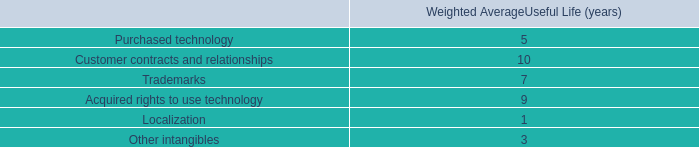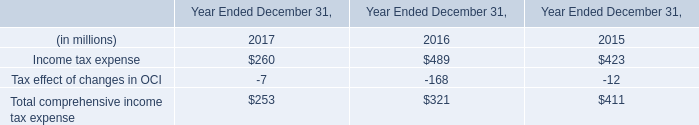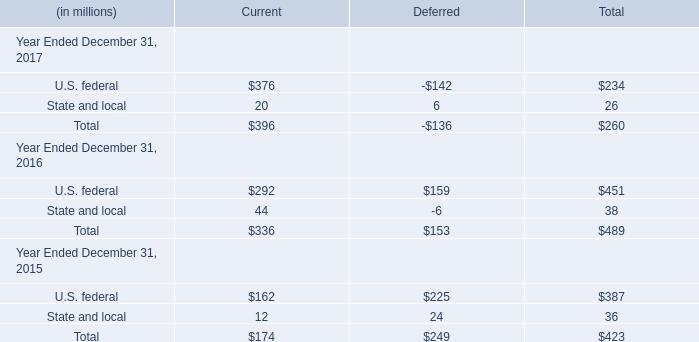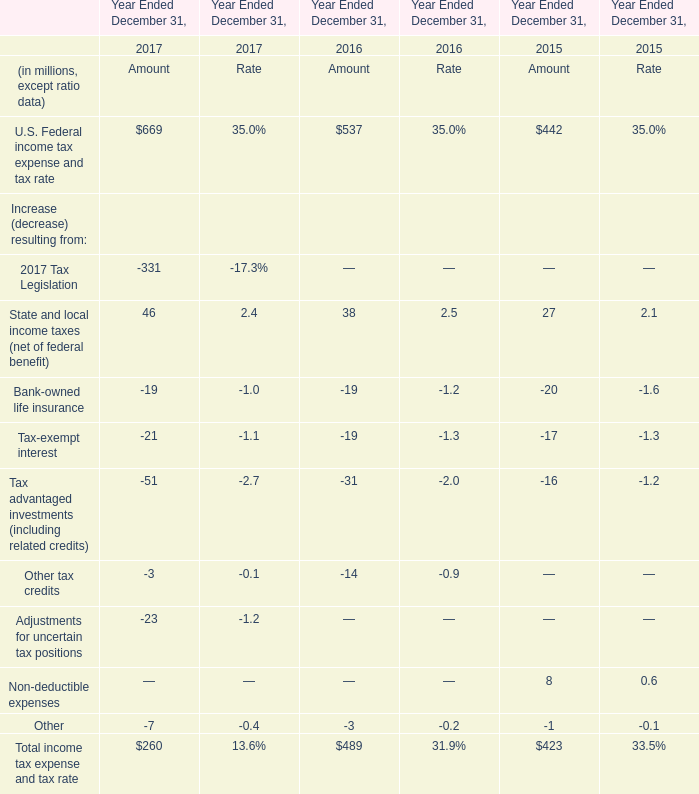Does State and local for Current keeps increasing each year between 2017 and 2016? 
Answer: No. 